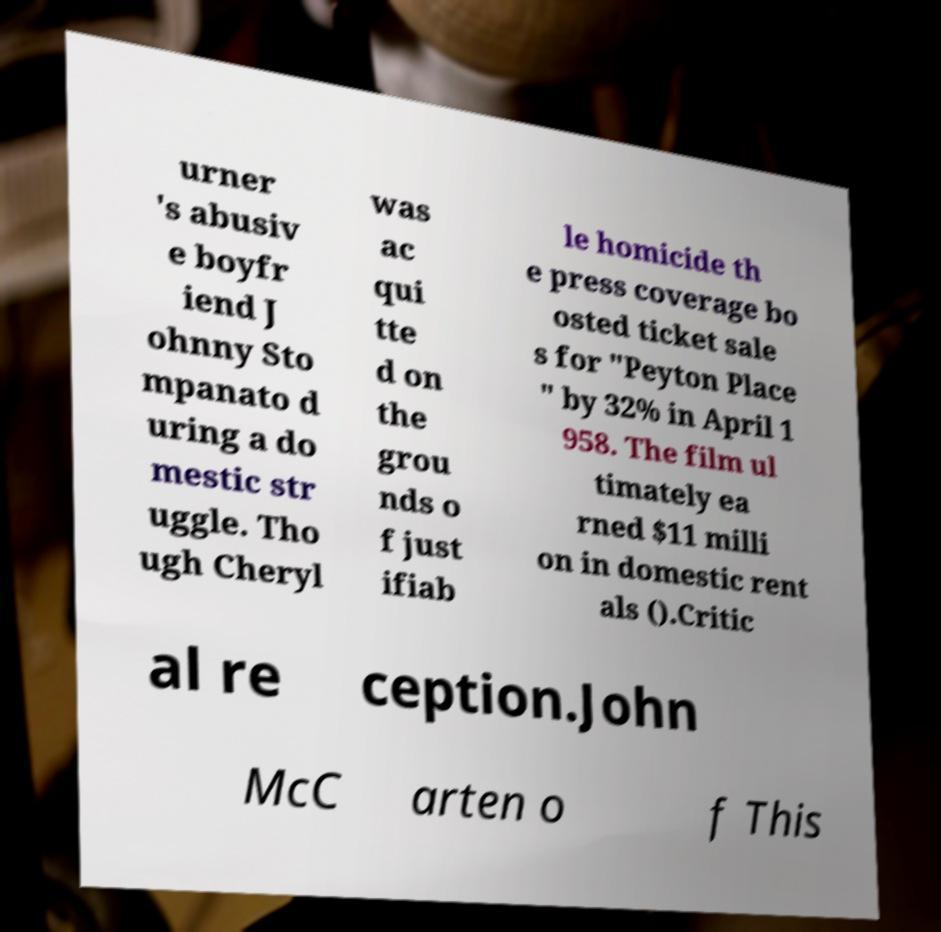Can you read and provide the text displayed in the image?This photo seems to have some interesting text. Can you extract and type it out for me? urner 's abusiv e boyfr iend J ohnny Sto mpanato d uring a do mestic str uggle. Tho ugh Cheryl was ac qui tte d on the grou nds o f just ifiab le homicide th e press coverage bo osted ticket sale s for "Peyton Place " by 32% in April 1 958. The film ul timately ea rned $11 milli on in domestic rent als ().Critic al re ception.John McC arten o f This 